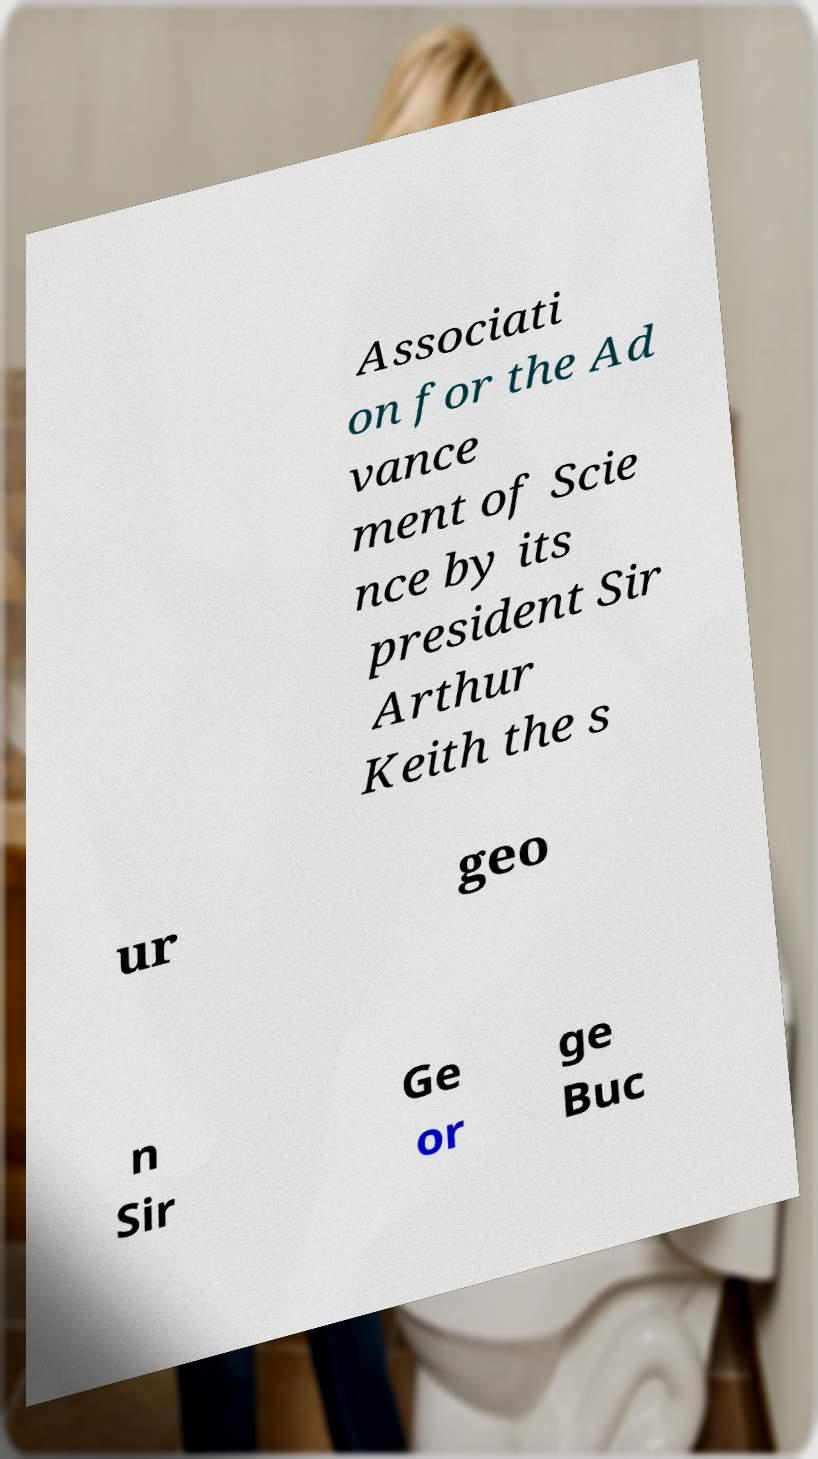Can you read and provide the text displayed in the image?This photo seems to have some interesting text. Can you extract and type it out for me? Associati on for the Ad vance ment of Scie nce by its president Sir Arthur Keith the s ur geo n Sir Ge or ge Buc 